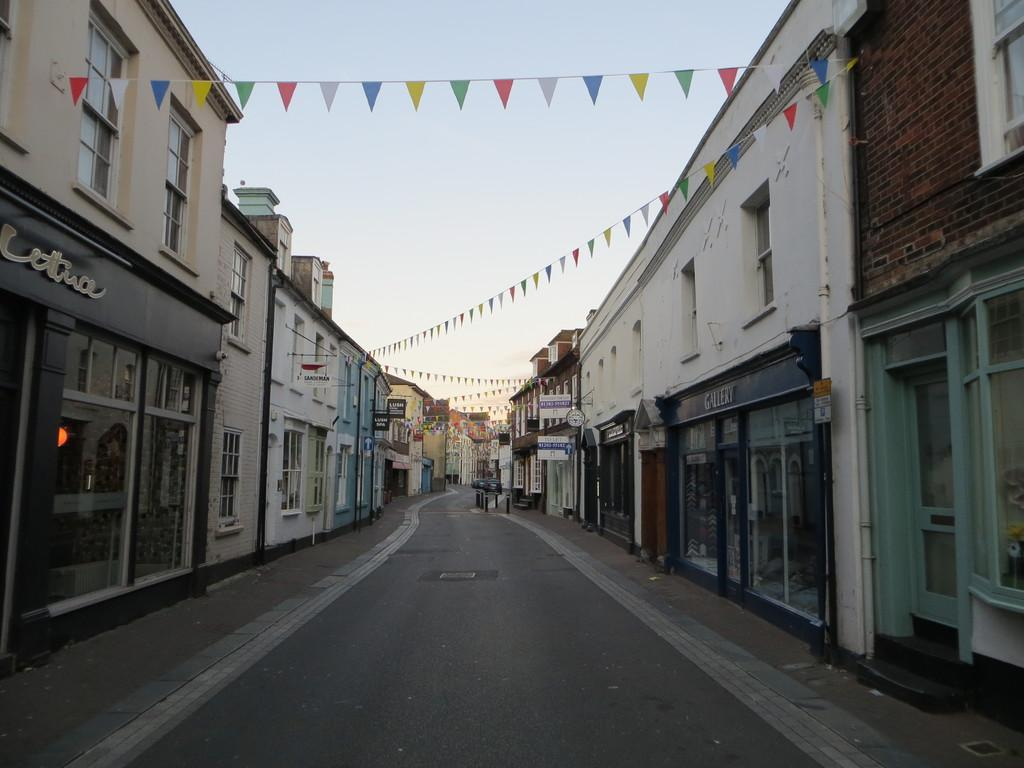What type of structures can be seen in the image? There are many buildings in the image. What else is visible in the image besides the buildings? Flags are present in the image. What is visible at the top of the image? The sky is visible at the top of the image. What is located at the bottom of the image? There is a road at the bottom of the image. What type of noise can be heard coming from the crowd in the image? There is no crowd present in the image, so it's not possible to determine what noise might be heard. 